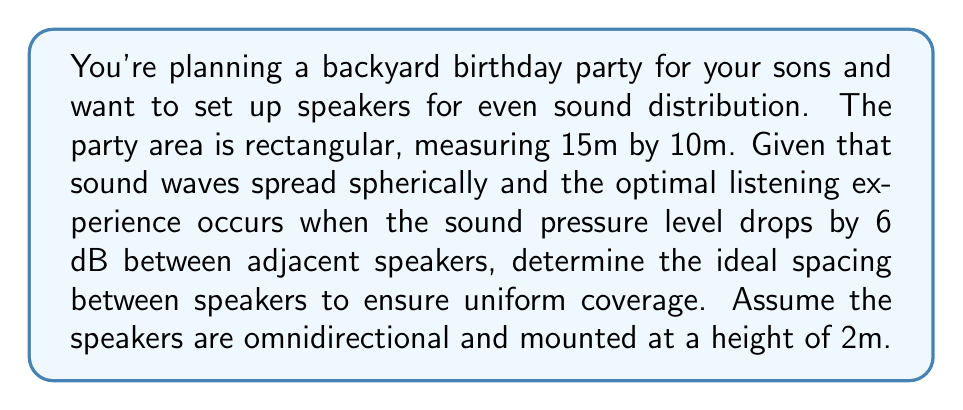Provide a solution to this math problem. To solve this problem, we'll follow these steps:

1) First, recall that sound intensity decreases with the square of the distance from the source. The sound pressure level (SPL) is related to intensity by:

   $$ \text{SPL} = 10 \log_{10} \left(\frac{I}{I_0}\right) $$

   where $I$ is the intensity and $I_0$ is the reference intensity.

2) A 6 dB drop in SPL corresponds to a factor of 4 decrease in intensity:

   $$ 6 = 10 \log_{10} \left(\frac{I_1}{I_2}\right) $$
   $$ \frac{I_1}{I_2} = 10^{0.6} = 4 $$

3) Let $r$ be the radius of effective coverage for each speaker. At distance $2r$, the intensity will be 1/4 of what it is at distance $r$. This gives us our optimal spacing.

4) To find $r$, we need to consider the height of the speakers. The effective distance on the ground is related to the height by the Pythagorean theorem:

   $$ r^2 + 2^2 = R^2 $$

   where $R$ is the actual distance from the speaker to the edge of its coverage area.

5) The optimal spacing between speakers is $2r$. Solving for $r$:

   $$ r = \sqrt{R^2 - 2^2} $$

6) To cover the entire area, we need:

   $$ \text{Number of speakers along length} = \left\lceil\frac{15}{2r}\right\rceil $$
   $$ \text{Number of speakers along width} = \left\lceil\frac{10}{2r}\right\rceil $$

7) We want to minimize the total number of speakers while ensuring full coverage. Through iteration, we find that $R \approx 5.2m$ gives an optimal solution:

   $$ r = \sqrt{5.2^2 - 2^2} \approx 4.8m $$

   This results in a $2r \approx 9.6m$ spacing, requiring 2 speakers along the length and 2 along the width, for a total of 4 speakers.
Answer: Optimal speaker spacing: 9.6m 